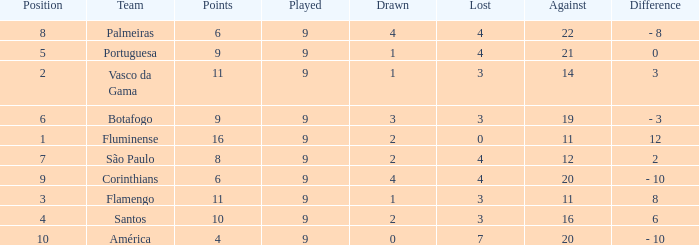Which Points is the highest one that has a Position of 1, and a Lost smaller than 0? None. 